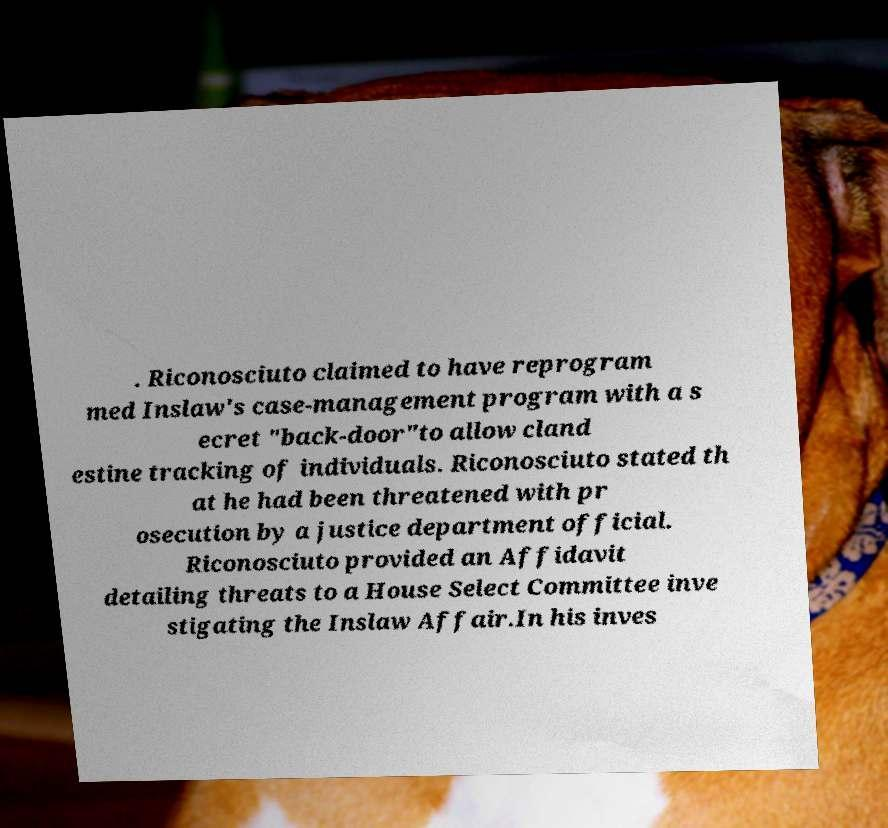For documentation purposes, I need the text within this image transcribed. Could you provide that? . Riconosciuto claimed to have reprogram med Inslaw's case-management program with a s ecret "back-door"to allow cland estine tracking of individuals. Riconosciuto stated th at he had been threatened with pr osecution by a justice department official. Riconosciuto provided an Affidavit detailing threats to a House Select Committee inve stigating the Inslaw Affair.In his inves 